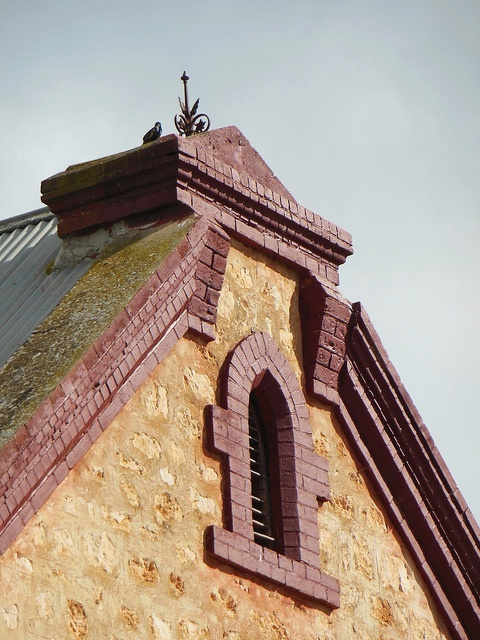Describe the objects in this image and their specific colors. I can see a bird in darkgray, black, gray, and navy tones in this image. 